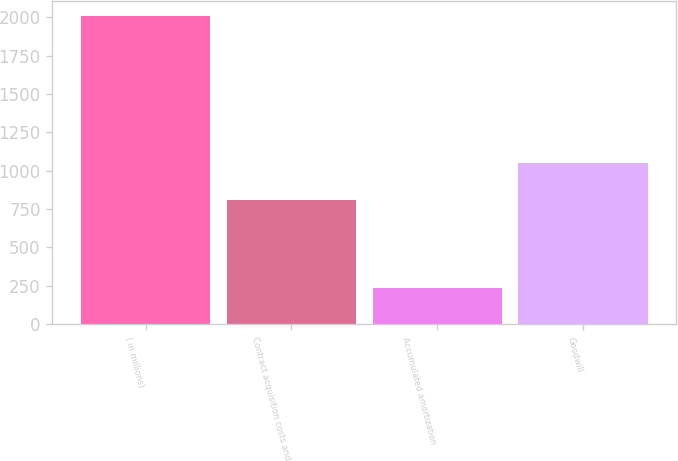Convert chart. <chart><loc_0><loc_0><loc_500><loc_500><bar_chart><fcel>( in millions)<fcel>Contract acquisition costs and<fcel>Accumulated amortization<fcel>Goodwill<nl><fcel>2006<fcel>809<fcel>234<fcel>1049<nl></chart> 